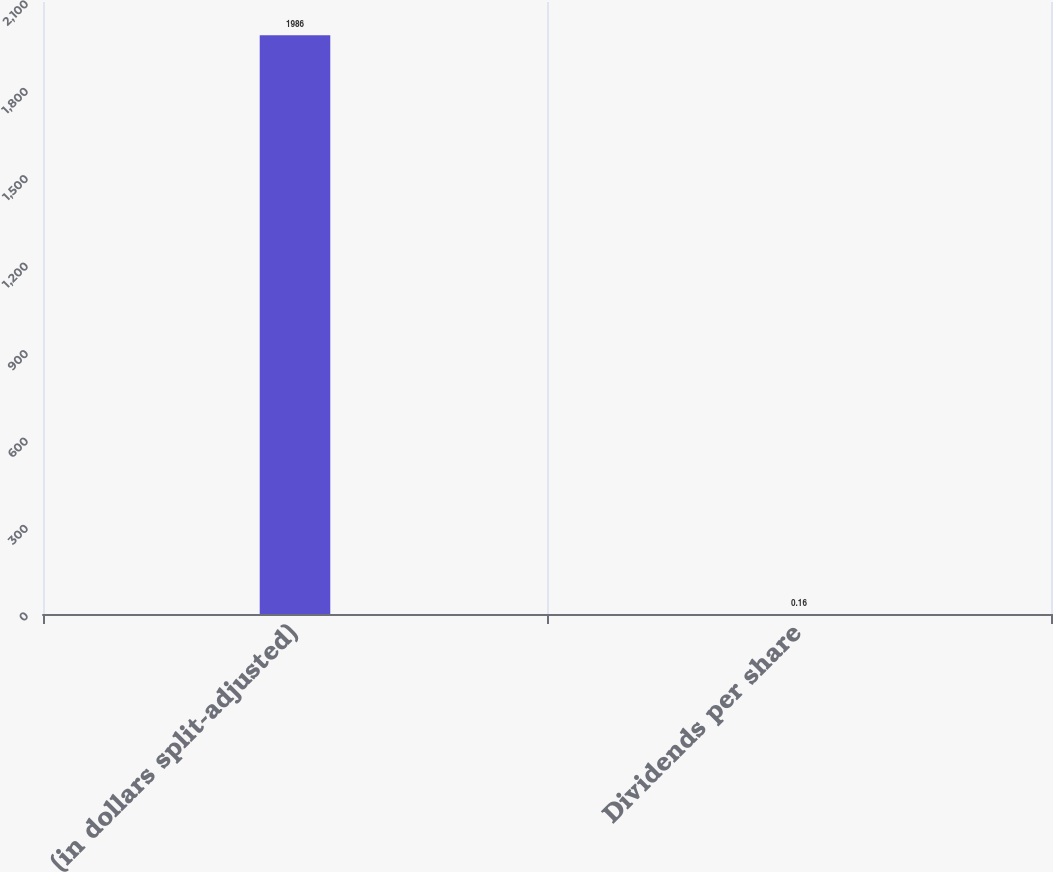<chart> <loc_0><loc_0><loc_500><loc_500><bar_chart><fcel>(in dollars split-adjusted)<fcel>Dividends per share<nl><fcel>1986<fcel>0.16<nl></chart> 